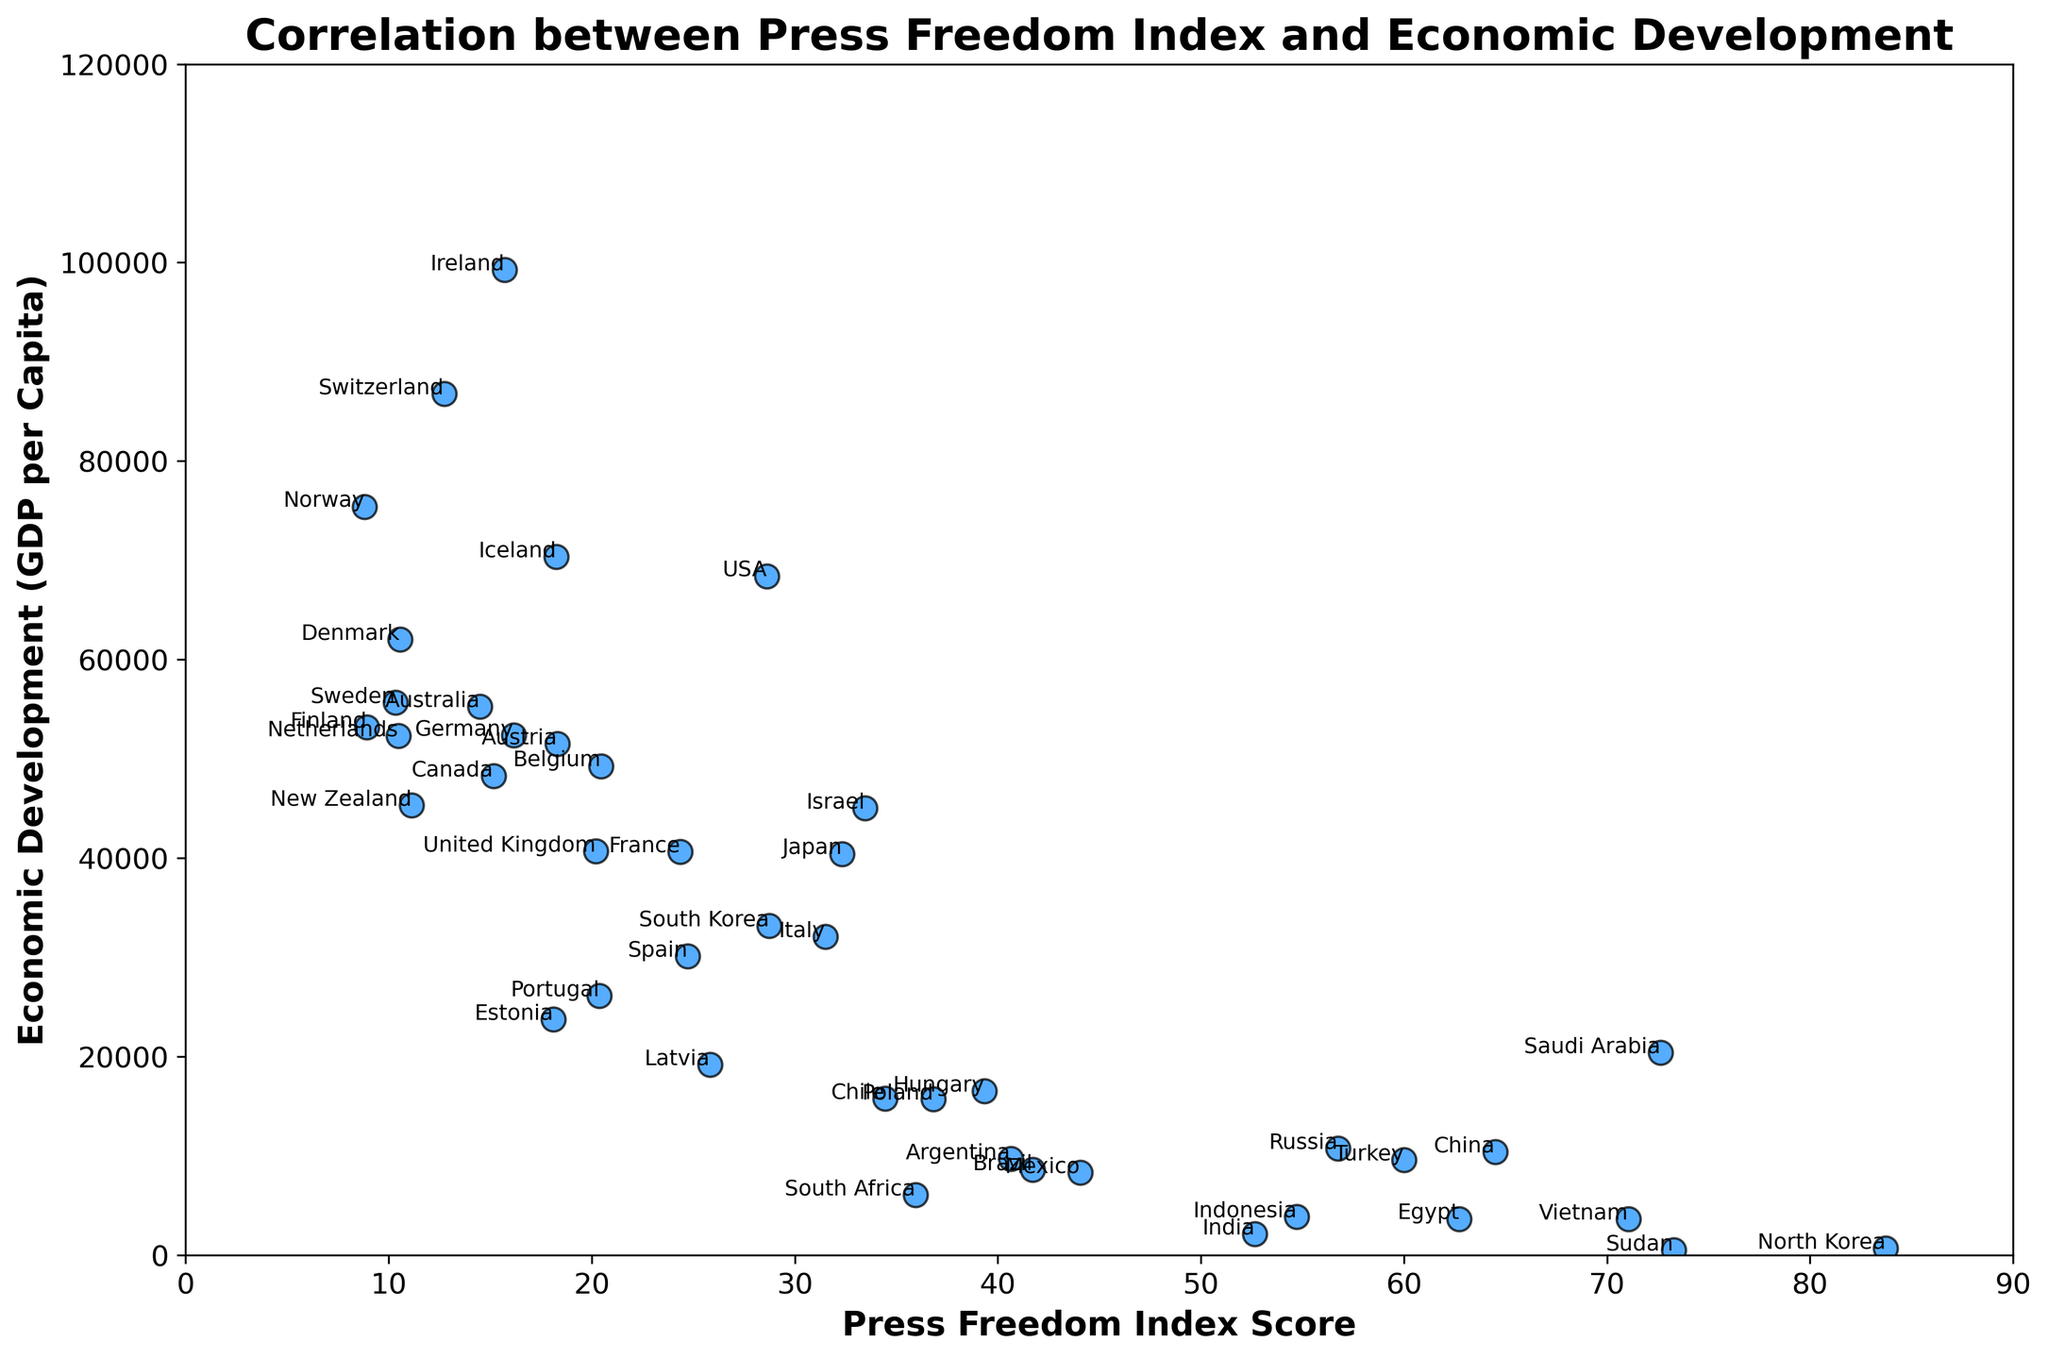Which country has the highest GDP per capita and what is its Press Freedom Index Score? Norway has the highest GDP per capita among the countries listed. Looking at the plot, the country located at the highest y-value is Ireland. Annotating its x-coordinate, we see that Ireland's Press Freedom Index Score is 15.72.
Answer: Ireland, 15.72 Which country has the lowest Press Freedom Index Score and what is its GDP per capita? The country with the lowest Press Freedom Index Score is the one closest to the x-axis origin. This is Norway with a Press Freedom Index Score of 8.82 and a GDP per capita of 75420.
Answer: Norway, 75420 How does North Korea's GDP per capita compare to China's? North Korea and China are both labeled on the plot. North Korea's GDP per capita is significantly lower than China's. North Korea's GDP per capita is around 700, while China's is noted as 10410, indicating China has a much higher GDP per capita.
Answer: China's GDP per capita is higher What is the average GDP per capita for Norway, Finland, and Sweden? The GDP per capita values for Norway, Finland, and Sweden are 75420, 53218, and 55660 respectively. Summing these values gives 184298. Dividing by 3 gives the average: 184298 / 3 = 61432.67.
Answer: 61432.67 Which country has the highest Press Freedom Index Score and what is its GDP per capita? The country with the highest Press Freedom Index Score is North Korea, located at the far right end of the x-axis. Its GDP per capita is noted as 700.
Answer: North Korea, 700 Are there any countries with both a high Press Freedom Index Score and a high GDP per capita? High GDP per capita can be considered values in the upper range of the y-axis, while high Press Freedom Index Score would be in the higher range of the x-axis. No country in the plot appears in both the high Press Freedom Index Score and high GDP per capita ranges.
Answer: No How does the GDP per capita of the USA compare to China's? Locate the USA and China on the plot. The USA's GDP per capita is significantly higher than China's. The GDP per capita for the USA is around 68405, while China's GDP per capita is 10410.
Answer: The USA’s GDP per capita is higher 